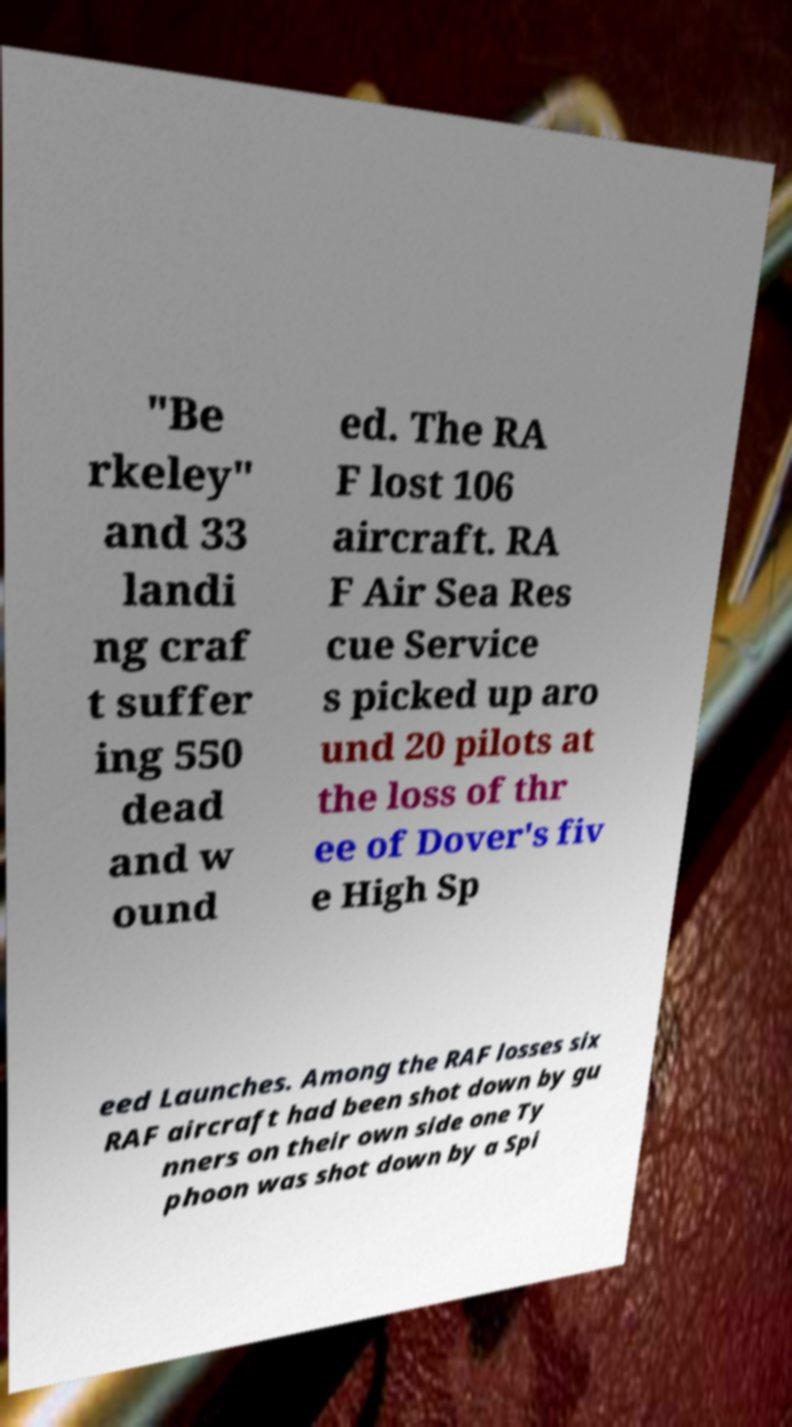There's text embedded in this image that I need extracted. Can you transcribe it verbatim? "Be rkeley" and 33 landi ng craf t suffer ing 550 dead and w ound ed. The RA F lost 106 aircraft. RA F Air Sea Res cue Service s picked up aro und 20 pilots at the loss of thr ee of Dover's fiv e High Sp eed Launches. Among the RAF losses six RAF aircraft had been shot down by gu nners on their own side one Ty phoon was shot down by a Spi 